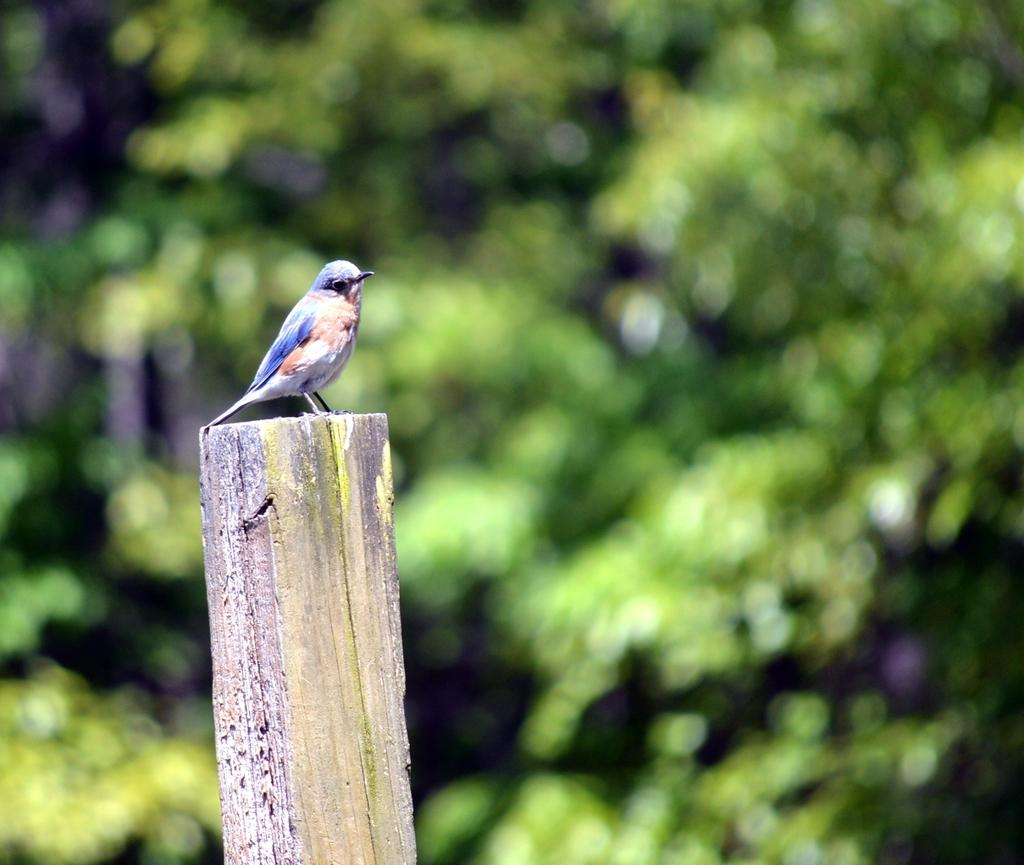What type of animal is in the image? There is a bird in the image. What is the bird standing on? The bird is standing on a wooden trunk. What can be seen in the background of the image? There are trees visible in the background of the image. How many frogs are sitting in the tub in the image? There is no tub or frogs present in the image. What is the relation between the bird and the trees in the image? The image does not depict a relationship between the bird and the trees; it simply shows the bird standing on a wooden trunk with trees visible in the background. 